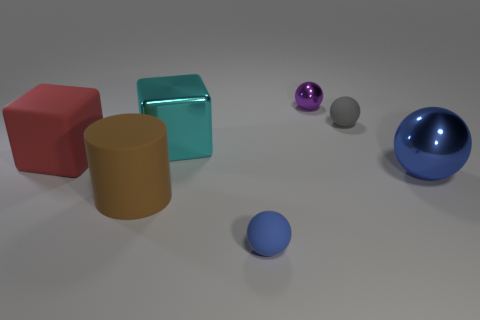Add 2 large green cylinders. How many objects exist? 9 Subtract all cylinders. How many objects are left? 6 Subtract 2 blue balls. How many objects are left? 5 Subtract all large red blocks. Subtract all big blue shiny balls. How many objects are left? 5 Add 2 cyan metallic cubes. How many cyan metallic cubes are left? 3 Add 3 tiny matte spheres. How many tiny matte spheres exist? 5 